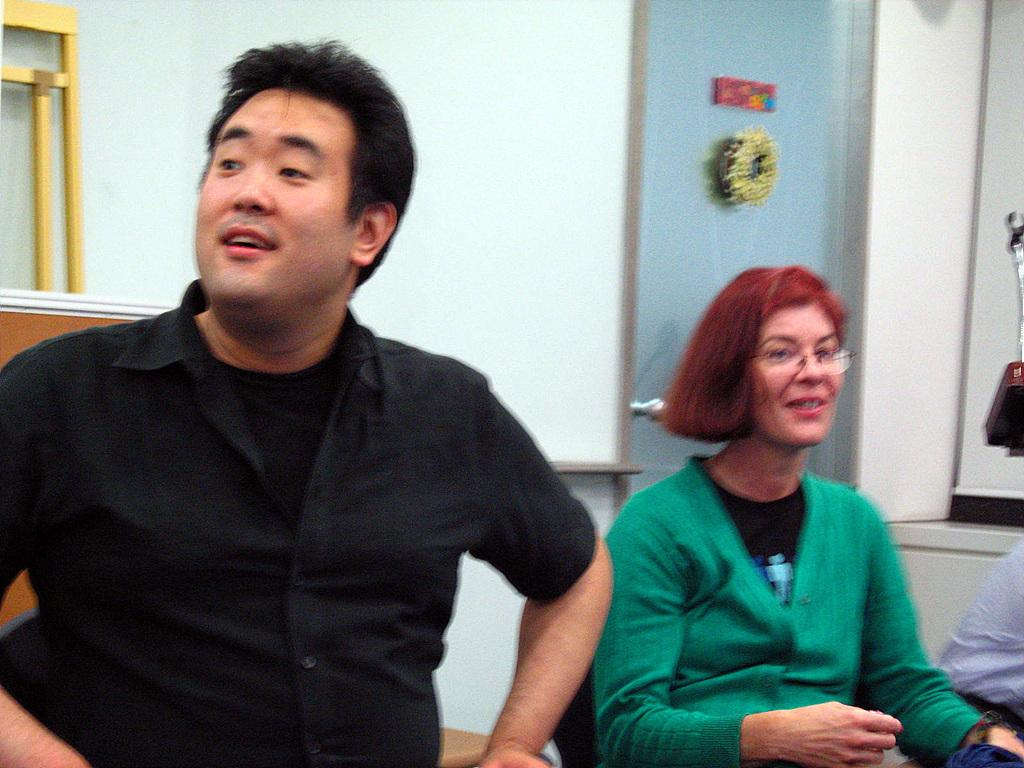What is the gender of the person in the image wearing a black dress? The person wearing a black dress is a man. What color is the dress worn by the man in the image? The man is wearing a black dress. What is the gender of the person in the image wearing a green dress? The person wearing a green dress is a woman. What color is the dress worn by the woman in the image? The woman is wearing a green dress. What can be seen in the background of the image? There is a wall in the background of the image. What type of basin is visible in the image? There is no basin present in the image. What scientific experiment is being conducted in the image? There is no scientific experiment depicted in the image. 